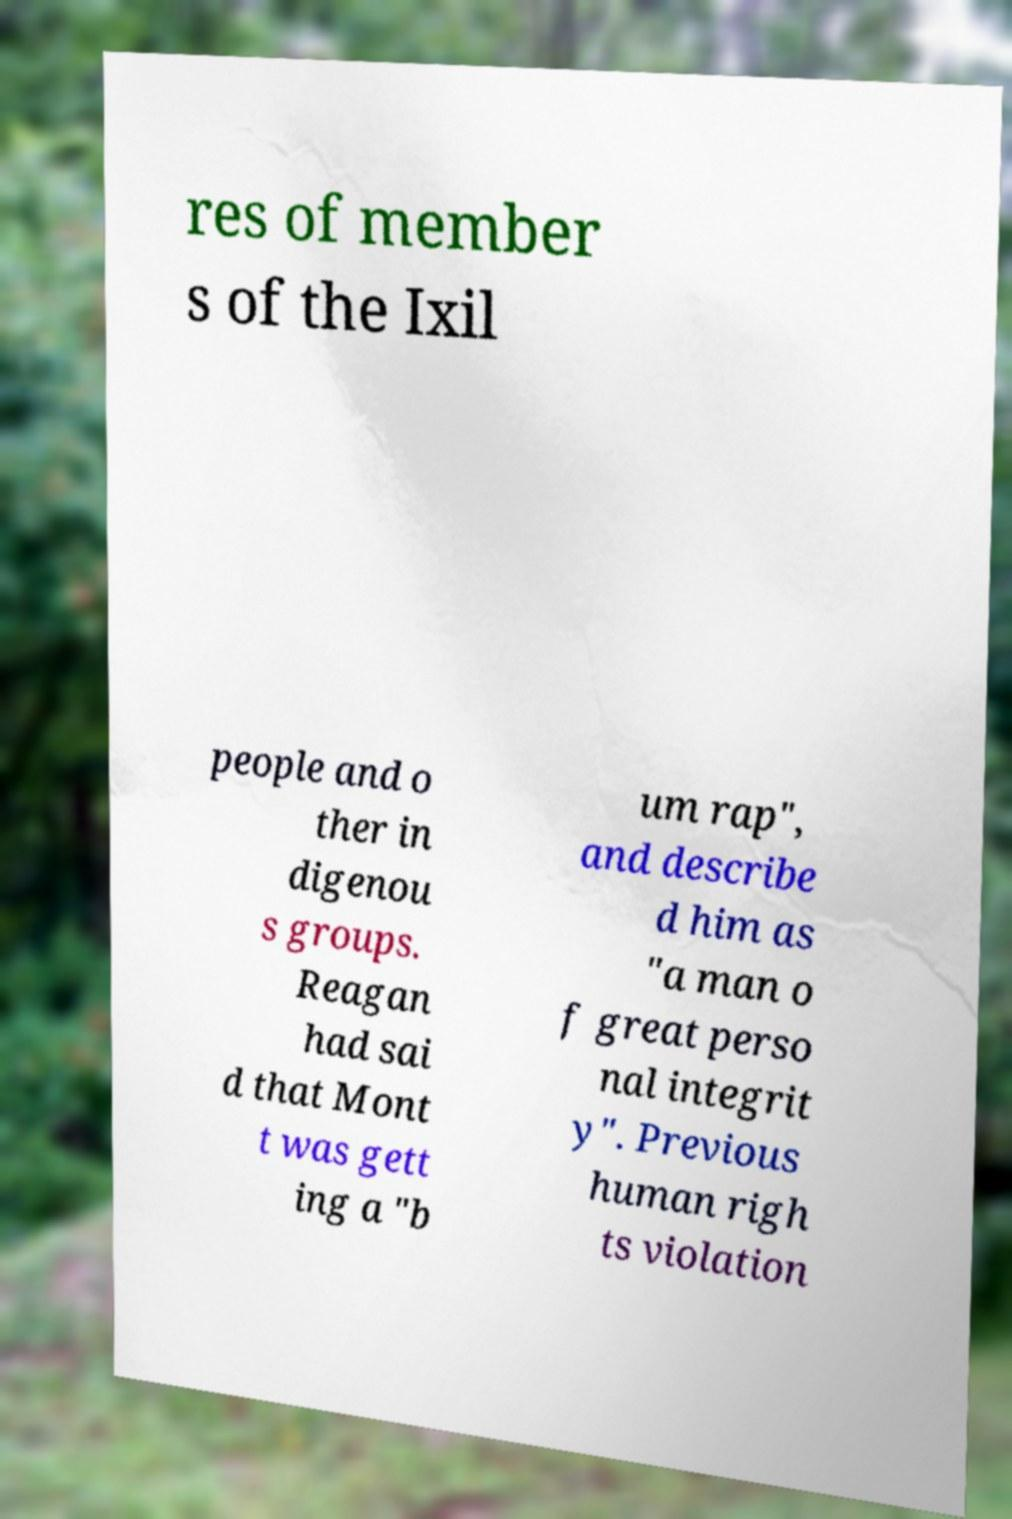For documentation purposes, I need the text within this image transcribed. Could you provide that? res of member s of the Ixil people and o ther in digenou s groups. Reagan had sai d that Mont t was gett ing a "b um rap", and describe d him as "a man o f great perso nal integrit y". Previous human righ ts violation 